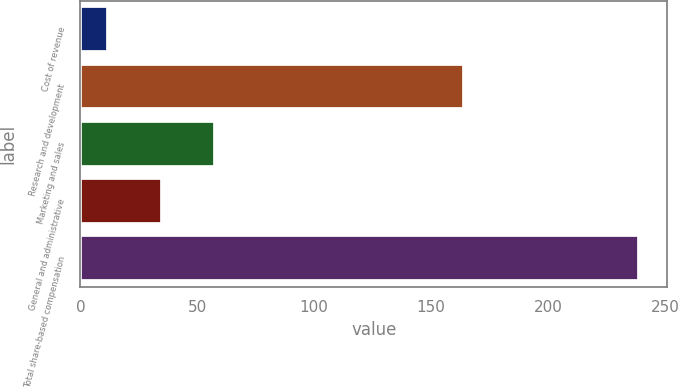Convert chart. <chart><loc_0><loc_0><loc_500><loc_500><bar_chart><fcel>Cost of revenue<fcel>Research and development<fcel>Marketing and sales<fcel>General and administrative<fcel>Total share-based compensation<nl><fcel>12<fcel>164<fcel>57.4<fcel>34.7<fcel>239<nl></chart> 